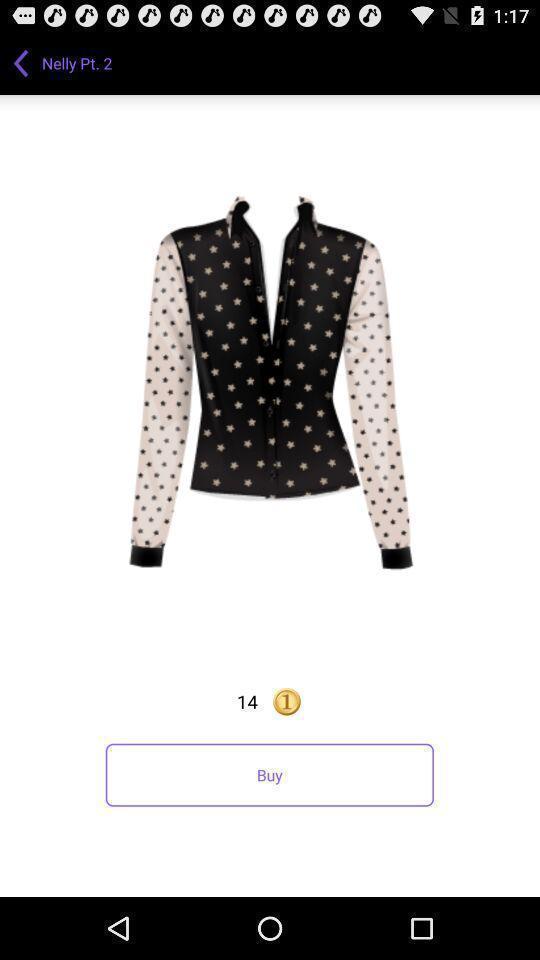Summarize the main components in this picture. Shopping app displayed an item to buy. 